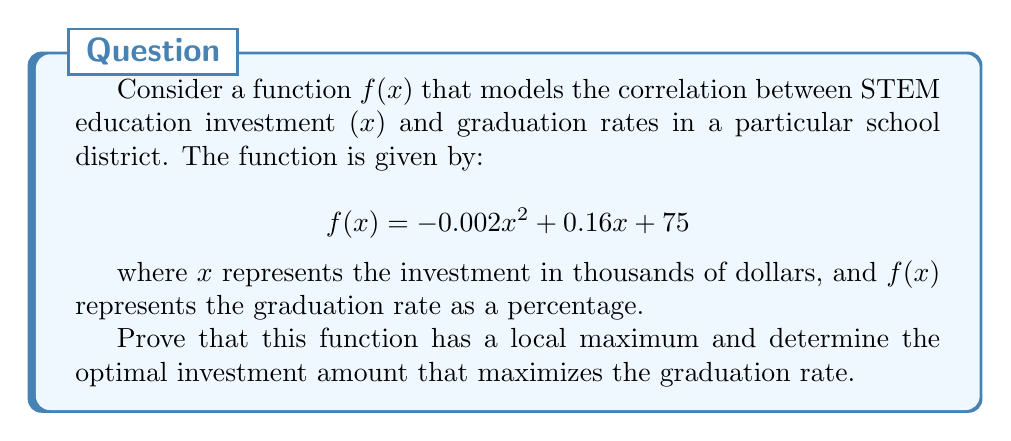Help me with this question. To prove the existence of a local maximum and find the optimal investment amount, we'll follow these steps:

1) First, we need to find the critical points of the function. To do this, we calculate the first derivative and set it equal to zero:

   $$f'(x) = -0.004x + 0.16$$
   
   Set $f'(x) = 0$:
   $$-0.004x + 0.16 = 0$$
   $$-0.004x = -0.16$$
   $$x = 40$$

2) We've found a critical point at $x = 40$. To determine if this is a local maximum, we need to examine the second derivative:

   $$f''(x) = -0.004$$

3) Since $f''(x)$ is a constant and it's negative, we can conclude that the function is concave down for all $x$. This means that the critical point at $x = 40$ is indeed a local maximum.

4) To further verify, we can check the values of $f(x)$ around $x = 40$:

   $$f(39) = -0.002(39)^2 + 0.16(39) + 75 = 78.198$$
   $$f(40) = -0.002(40)^2 + 0.16(40) + 75 = 78.2$$
   $$f(41) = -0.002(41)^2 + 0.16(41) + 75 = 78.198$$

   We can see that $f(40)$ is greater than both $f(39)$ and $f(41)$, confirming it's a local maximum.

5) The maximum graduation rate can be calculated by plugging $x = 40$ into the original function:

   $$f(40) = -0.002(40)^2 + 0.16(40) + 75 = 78.2\%$$

Therefore, we have proved that the function has a local maximum at $x = 40$, which represents an optimal investment of $40,000 in STEM education to achieve a maximum graduation rate of 78.2%.
Answer: The function has a local maximum at $x = 40$, corresponding to an optimal STEM education investment of $40,000, which results in a maximum graduation rate of 78.2%. 